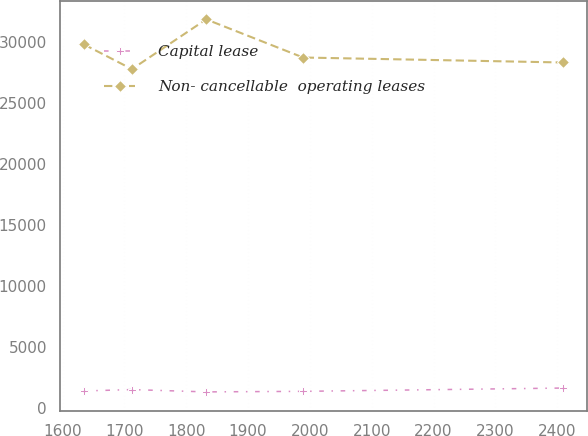<chart> <loc_0><loc_0><loc_500><loc_500><line_chart><ecel><fcel>Capital lease<fcel>Non- cancellable  operating leases<nl><fcel>1634.75<fcel>1377.52<fcel>29802.7<nl><fcel>1712.2<fcel>1490.49<fcel>27778.6<nl><fcel>1832.3<fcel>1300.4<fcel>31862.2<nl><fcel>1989.03<fcel>1345.9<fcel>28731.4<nl><fcel>2409.3<fcel>1616.56<fcel>28323<nl></chart> 